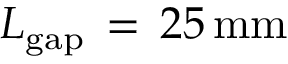Convert formula to latex. <formula><loc_0><loc_0><loc_500><loc_500>L _ { g a p } \, = \, 2 5 \, { m m }</formula> 